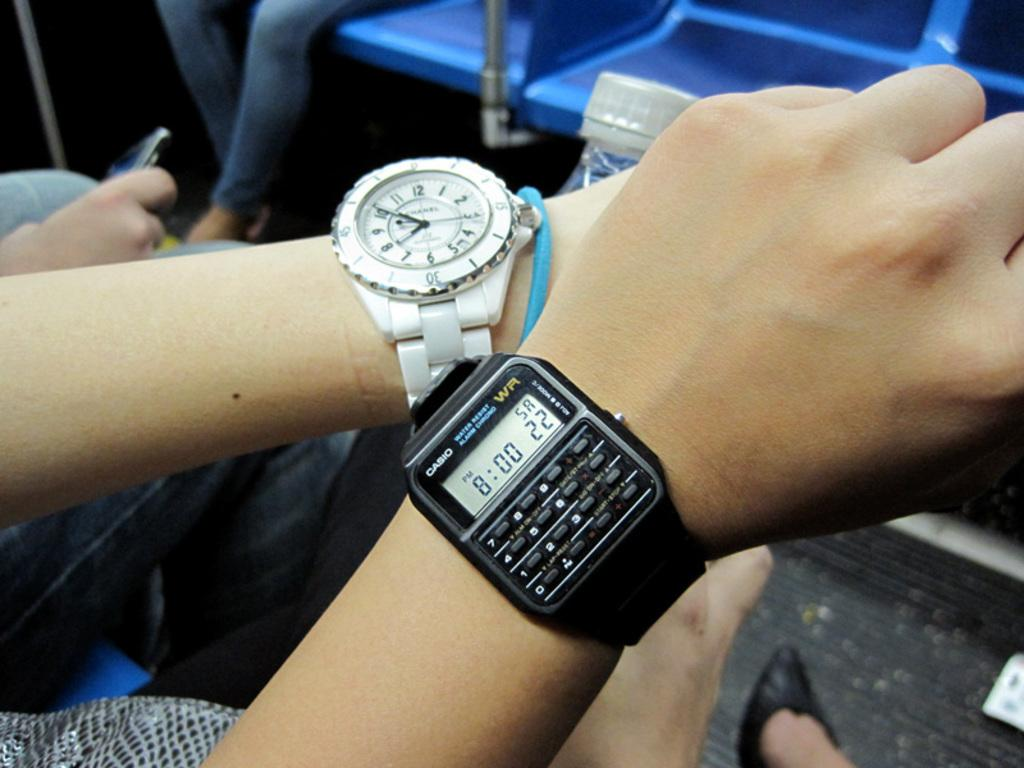<image>
Render a clear and concise summary of the photo. Person wearing a wrist watch which says the time at 8:00 on it. 